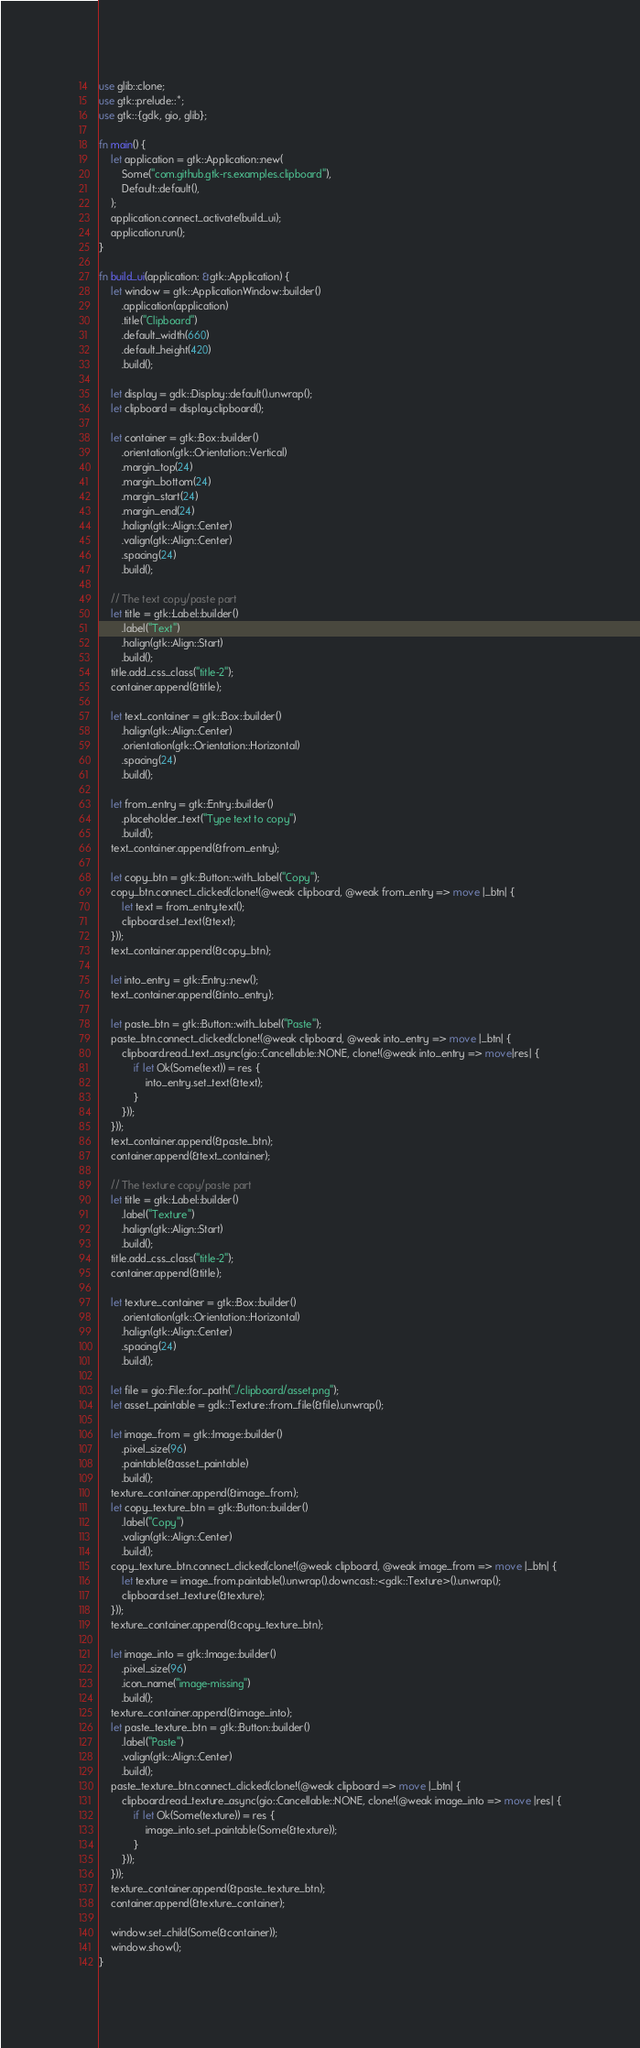<code> <loc_0><loc_0><loc_500><loc_500><_Rust_>use glib::clone;
use gtk::prelude::*;
use gtk::{gdk, gio, glib};

fn main() {
    let application = gtk::Application::new(
        Some("com.github.gtk-rs.examples.clipboard"),
        Default::default(),
    );
    application.connect_activate(build_ui);
    application.run();
}

fn build_ui(application: &gtk::Application) {
    let window = gtk::ApplicationWindow::builder()
        .application(application)
        .title("Clipboard")
        .default_width(660)
        .default_height(420)
        .build();

    let display = gdk::Display::default().unwrap();
    let clipboard = display.clipboard();

    let container = gtk::Box::builder()
        .orientation(gtk::Orientation::Vertical)
        .margin_top(24)
        .margin_bottom(24)
        .margin_start(24)
        .margin_end(24)
        .halign(gtk::Align::Center)
        .valign(gtk::Align::Center)
        .spacing(24)
        .build();

    // The text copy/paste part
    let title = gtk::Label::builder()
        .label("Text")
        .halign(gtk::Align::Start)
        .build();
    title.add_css_class("title-2");
    container.append(&title);

    let text_container = gtk::Box::builder()
        .halign(gtk::Align::Center)
        .orientation(gtk::Orientation::Horizontal)
        .spacing(24)
        .build();

    let from_entry = gtk::Entry::builder()
        .placeholder_text("Type text to copy")
        .build();
    text_container.append(&from_entry);

    let copy_btn = gtk::Button::with_label("Copy");
    copy_btn.connect_clicked(clone!(@weak clipboard, @weak from_entry => move |_btn| {
        let text = from_entry.text();
        clipboard.set_text(&text);
    }));
    text_container.append(&copy_btn);

    let into_entry = gtk::Entry::new();
    text_container.append(&into_entry);

    let paste_btn = gtk::Button::with_label("Paste");
    paste_btn.connect_clicked(clone!(@weak clipboard, @weak into_entry => move |_btn| {
        clipboard.read_text_async(gio::Cancellable::NONE, clone!(@weak into_entry => move|res| {
            if let Ok(Some(text)) = res {
                into_entry.set_text(&text);
            }
        }));
    }));
    text_container.append(&paste_btn);
    container.append(&text_container);

    // The texture copy/paste part
    let title = gtk::Label::builder()
        .label("Texture")
        .halign(gtk::Align::Start)
        .build();
    title.add_css_class("title-2");
    container.append(&title);

    let texture_container = gtk::Box::builder()
        .orientation(gtk::Orientation::Horizontal)
        .halign(gtk::Align::Center)
        .spacing(24)
        .build();

    let file = gio::File::for_path("./clipboard/asset.png");
    let asset_paintable = gdk::Texture::from_file(&file).unwrap();

    let image_from = gtk::Image::builder()
        .pixel_size(96)
        .paintable(&asset_paintable)
        .build();
    texture_container.append(&image_from);
    let copy_texture_btn = gtk::Button::builder()
        .label("Copy")
        .valign(gtk::Align::Center)
        .build();
    copy_texture_btn.connect_clicked(clone!(@weak clipboard, @weak image_from => move |_btn| {
        let texture = image_from.paintable().unwrap().downcast::<gdk::Texture>().unwrap();
        clipboard.set_texture(&texture);
    }));
    texture_container.append(&copy_texture_btn);

    let image_into = gtk::Image::builder()
        .pixel_size(96)
        .icon_name("image-missing")
        .build();
    texture_container.append(&image_into);
    let paste_texture_btn = gtk::Button::builder()
        .label("Paste")
        .valign(gtk::Align::Center)
        .build();
    paste_texture_btn.connect_clicked(clone!(@weak clipboard => move |_btn| {
        clipboard.read_texture_async(gio::Cancellable::NONE, clone!(@weak image_into => move |res| {
            if let Ok(Some(texture)) = res {
                image_into.set_paintable(Some(&texture));
            }
        }));
    }));
    texture_container.append(&paste_texture_btn);
    container.append(&texture_container);

    window.set_child(Some(&container));
    window.show();
}
</code> 